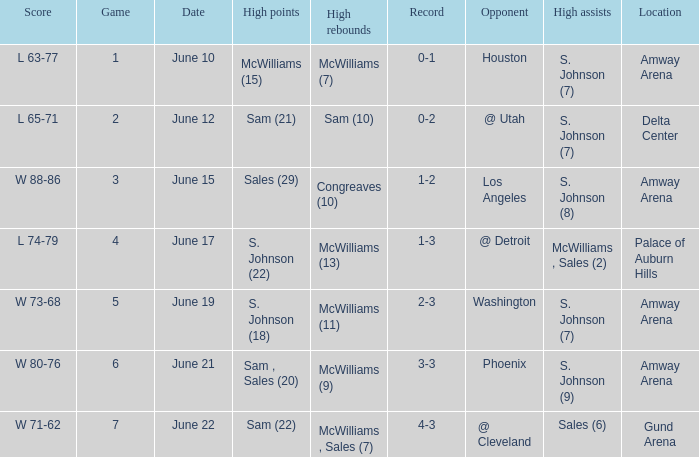Name the opponent for june 12 @ Utah. 